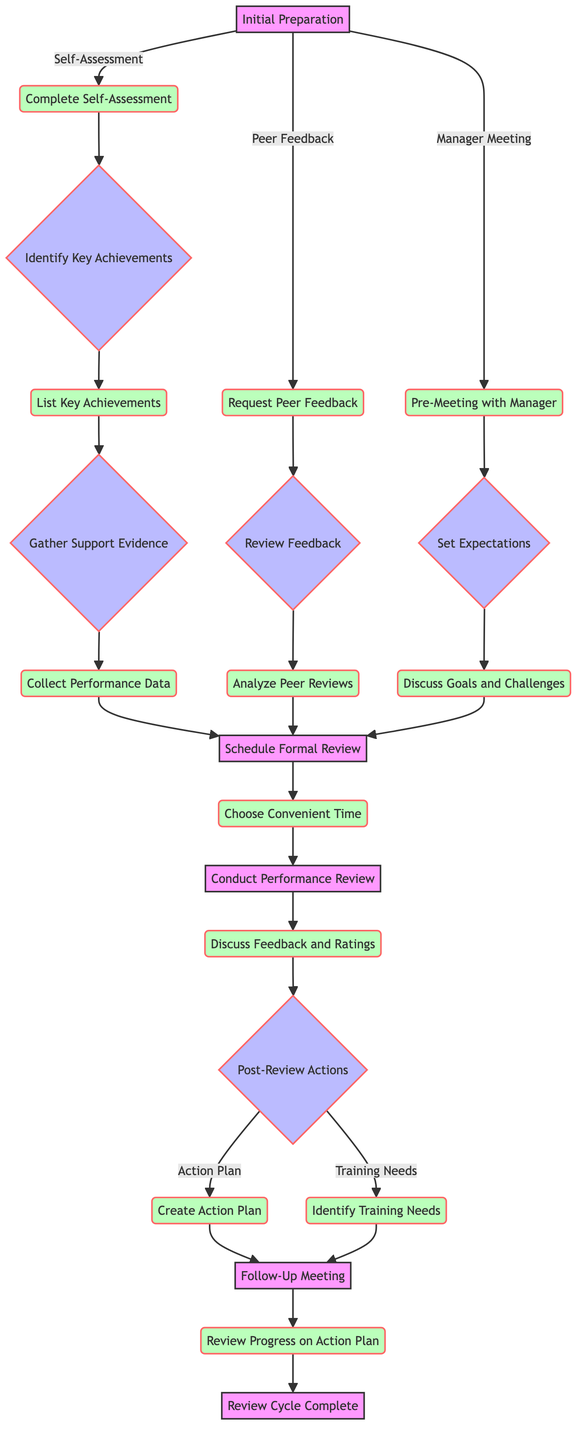What are the initial preparation options for performance reviews? The diagram shows three initial preparation options: Complete Self-Assessment, Request Peer Feedback, and Pre-Meeting with Manager.
Answer: Complete Self-Assessment, Request Peer Feedback, Pre-Meeting with Manager How many nodes are in the formal review stage? In the formal review stage, there are three nodes: Discuss Feedback and Ratings, Create Action Plan, and Identify Training Needs, which gives a total of three nodes.
Answer: 3 What is the next step after completing the self-assessment? After completing the self-assessment, the next step is to identify key achievements, leading to the next node.
Answer: Identify Key Achievements How many actions can be taken after the performance review discussion? Two actions can be taken after the discussion: Create Action Plan and Identify Training Needs, totaling two actions.
Answer: 2 Which option leads to the scheduling of the formal review? The scheduling of the formal review is led by the collection of performance data, peer review analysis, or discussion of goals and challenges, gathering them all into one node.
Answer: Collect Performance Data, Analyze Peer Reviews, Discuss Goals and Challenges What is the final step in the decision tree? The final step in the decision tree is labeled "Review Cycle Complete," which signifies the end of the process.
Answer: Review Cycle Complete What must be discussed during the pre-meeting with the manager? During the pre-meeting with the manager, the discussion must cover goals and challenges, which prepares for the expectations setting.
Answer: Discuss Goals and Challenges Which stage occurs just before scheduling the formal review? Just before scheduling the formal review, the diagram suggests completing steps related to gathering support evidence from key achievements or peer feedback analysis.
Answer: Gather Support Evidence What follows the follow-up meeting? After the follow-up meeting, the process ends with the completion of the review cycle.
Answer: Review Cycle Complete 